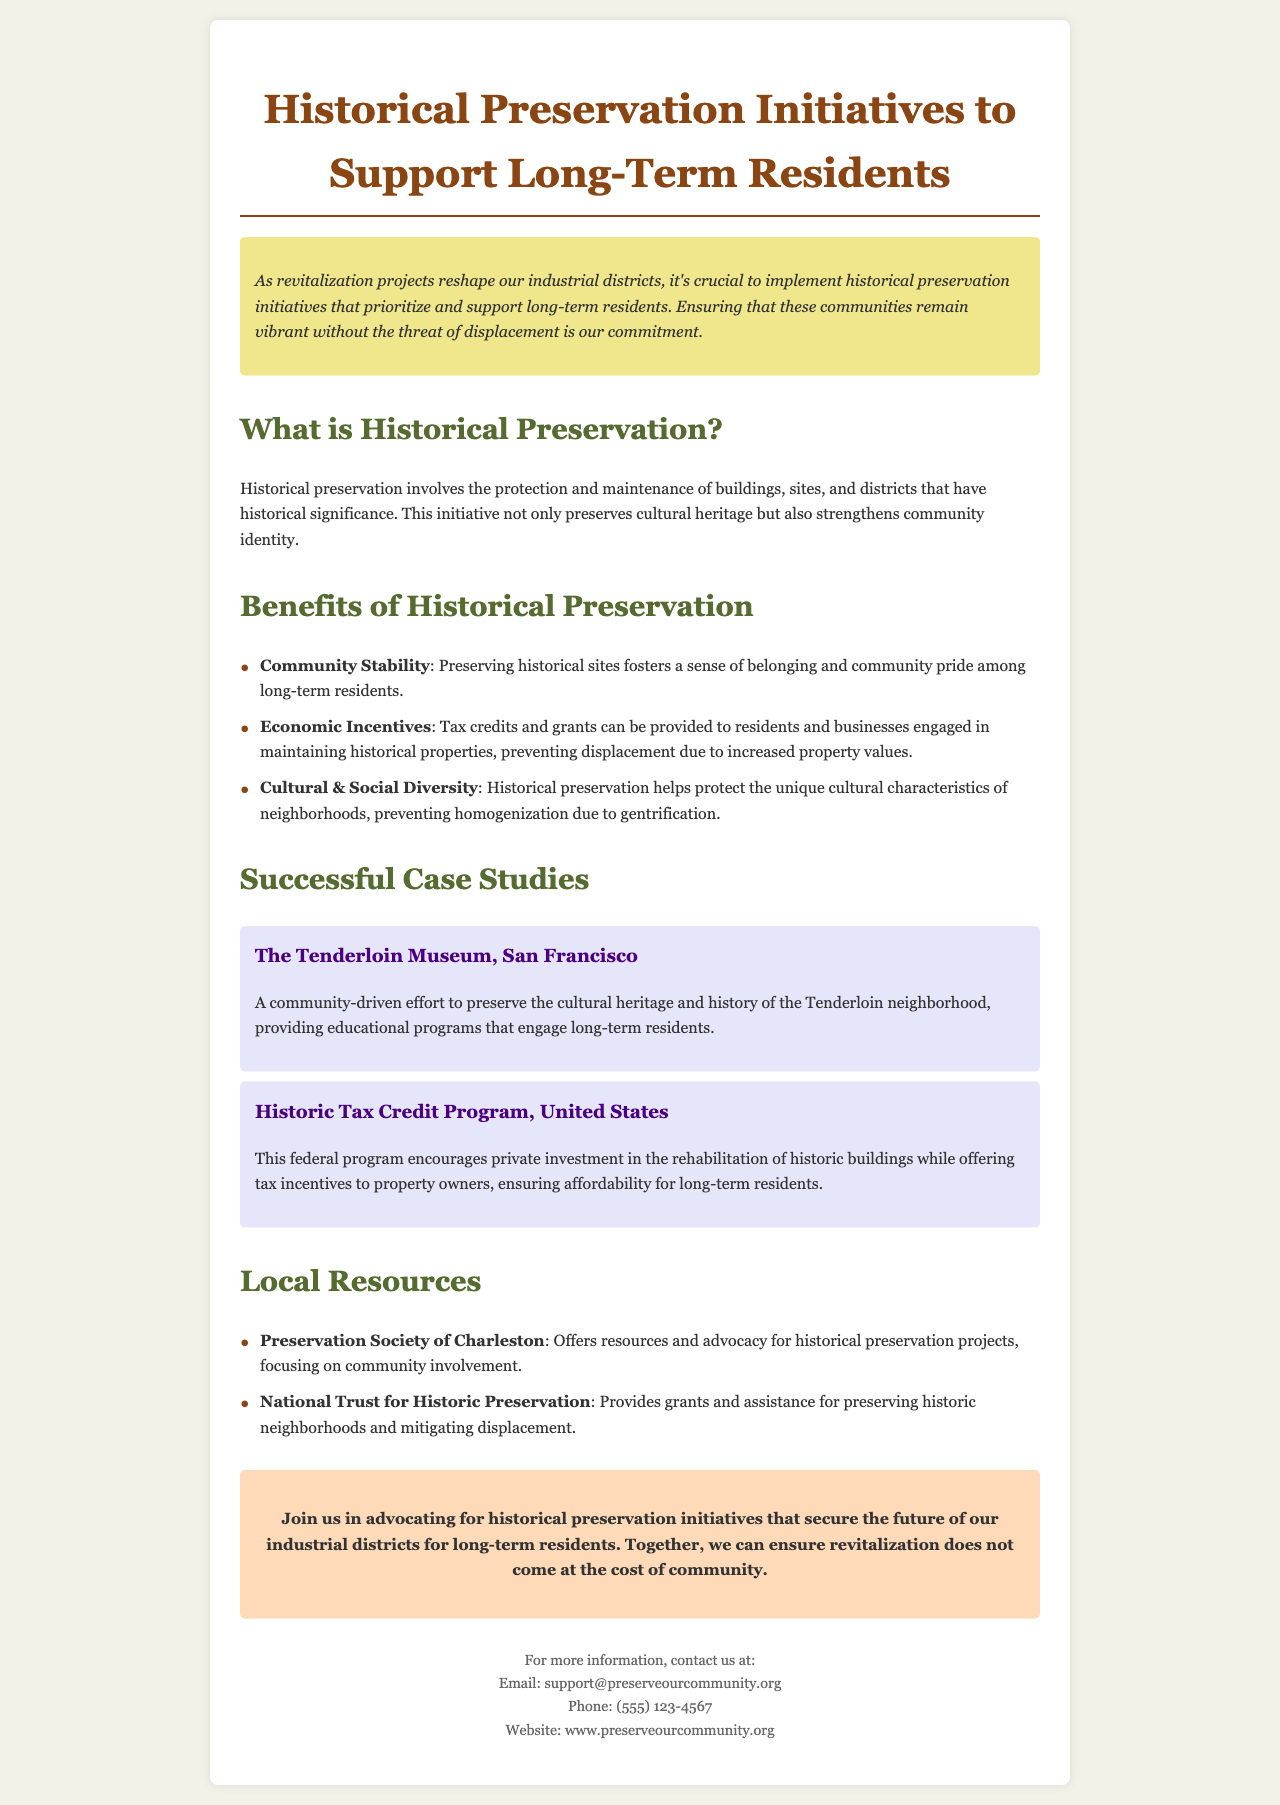What is the title of the brochure? The title is presented prominently at the top of the brochure.
Answer: Historical Preservation Initiatives to Support Long-Term Residents What is one benefit of historical preservation? The brochure lists several benefits under the corresponding section.
Answer: Community Stability Who is a local resource for historical preservation projects? The document provides a specific organization as a local resource.
Answer: Preservation Society of Charleston What case study is mentioned related to San Francisco? The brochure specifically highlights a case study from San Francisco.
Answer: The Tenderloin Museum What does the call-to-action suggest? The call-to-action encourages community involvement in a specific initiative.
Answer: Advocating for historical preservation initiatives How does historical preservation prevent displacement? This is inferred from the explanations provided in the document about economic incentives.
Answer: Tax credits and grants 